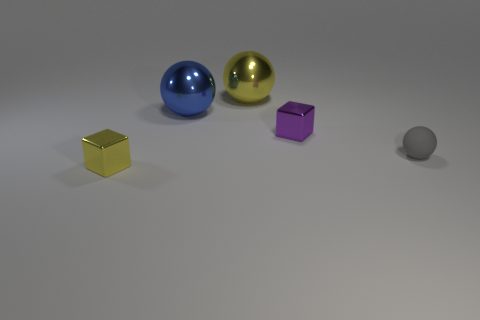Subtract all tiny gray matte spheres. How many spheres are left? 2 Add 4 big yellow things. How many objects exist? 9 Subtract all cubes. How many objects are left? 3 Subtract all large purple cylinders. Subtract all matte spheres. How many objects are left? 4 Add 1 small purple shiny blocks. How many small purple shiny blocks are left? 2 Add 1 tiny objects. How many tiny objects exist? 4 Subtract 0 gray cylinders. How many objects are left? 5 